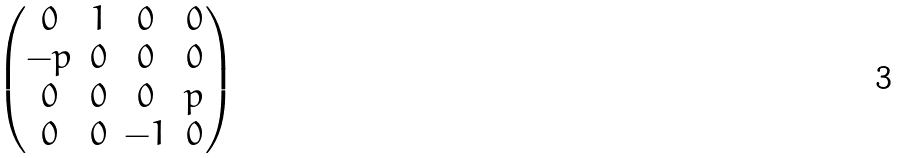<formula> <loc_0><loc_0><loc_500><loc_500>\begin{pmatrix} 0 & 1 & 0 & 0 \\ - p & 0 & 0 & 0 \\ 0 & 0 & 0 & p \\ 0 & 0 & - 1 & 0 \end{pmatrix}</formula> 